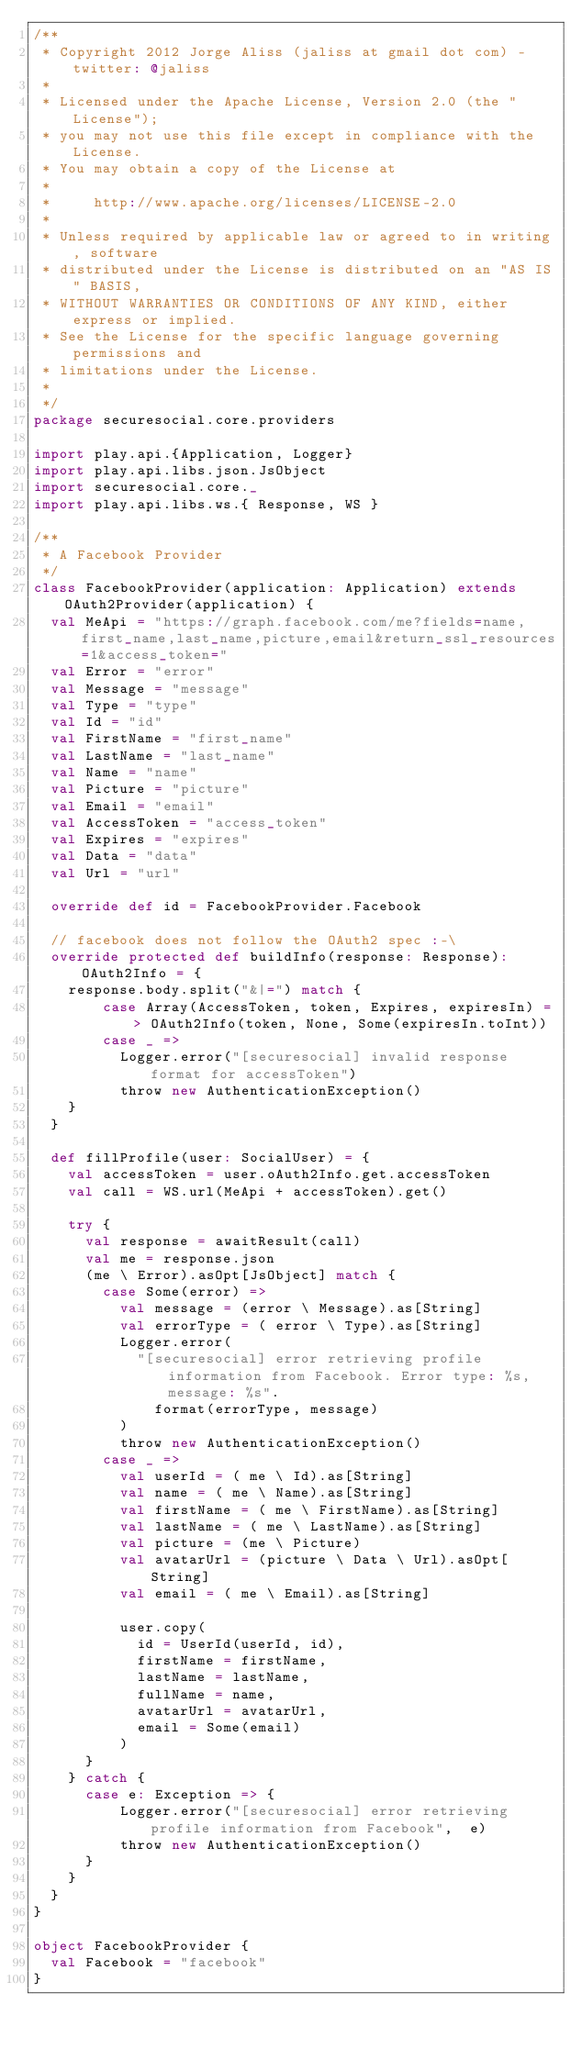<code> <loc_0><loc_0><loc_500><loc_500><_Scala_>/**
 * Copyright 2012 Jorge Aliss (jaliss at gmail dot com) - twitter: @jaliss
 *
 * Licensed under the Apache License, Version 2.0 (the "License");
 * you may not use this file except in compliance with the License.
 * You may obtain a copy of the License at
 *
 *     http://www.apache.org/licenses/LICENSE-2.0
 *
 * Unless required by applicable law or agreed to in writing, software
 * distributed under the License is distributed on an "AS IS" BASIS,
 * WITHOUT WARRANTIES OR CONDITIONS OF ANY KIND, either express or implied.
 * See the License for the specific language governing permissions and
 * limitations under the License.
 *
 */
package securesocial.core.providers

import play.api.{Application, Logger}
import play.api.libs.json.JsObject
import securesocial.core._
import play.api.libs.ws.{ Response, WS }

/**
 * A Facebook Provider
 */
class FacebookProvider(application: Application) extends OAuth2Provider(application) {
  val MeApi = "https://graph.facebook.com/me?fields=name,first_name,last_name,picture,email&return_ssl_resources=1&access_token="
  val Error = "error"
  val Message = "message"
  val Type = "type"
  val Id = "id"
  val FirstName = "first_name"
  val LastName = "last_name"
  val Name = "name"
  val Picture = "picture"
  val Email = "email"
  val AccessToken = "access_token"
  val Expires = "expires"
  val Data = "data"
  val Url = "url"

  override def id = FacebookProvider.Facebook

  // facebook does not follow the OAuth2 spec :-\
  override protected def buildInfo(response: Response): OAuth2Info = {
    response.body.split("&|=") match {
        case Array(AccessToken, token, Expires, expiresIn) => OAuth2Info(token, None, Some(expiresIn.toInt))
        case _ =>
          Logger.error("[securesocial] invalid response format for accessToken")
          throw new AuthenticationException()
    }
  }

  def fillProfile(user: SocialUser) = {
    val accessToken = user.oAuth2Info.get.accessToken
    val call = WS.url(MeApi + accessToken).get()

    try {
      val response = awaitResult(call)
      val me = response.json
      (me \ Error).asOpt[JsObject] match {
        case Some(error) =>
          val message = (error \ Message).as[String]
          val errorType = ( error \ Type).as[String]
          Logger.error(
            "[securesocial] error retrieving profile information from Facebook. Error type: %s, message: %s".
              format(errorType, message)
          )
          throw new AuthenticationException()
        case _ =>
          val userId = ( me \ Id).as[String]
          val name = ( me \ Name).as[String]
          val firstName = ( me \ FirstName).as[String]
          val lastName = ( me \ LastName).as[String]
          val picture = (me \ Picture)
          val avatarUrl = (picture \ Data \ Url).asOpt[String]
          val email = ( me \ Email).as[String]

          user.copy(
            id = UserId(userId, id),
            firstName = firstName,
            lastName = lastName,
            fullName = name,
            avatarUrl = avatarUrl,
            email = Some(email)
          )
      }
    } catch {
      case e: Exception => {
          Logger.error("[securesocial] error retrieving profile information from Facebook",  e)
          throw new AuthenticationException()
      }
    }
  }
}

object FacebookProvider {
  val Facebook = "facebook"
}</code> 